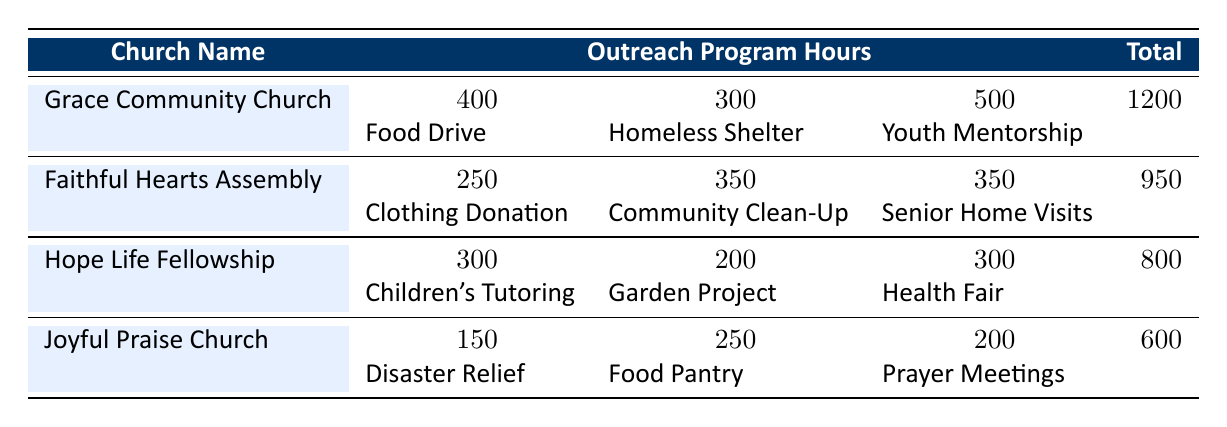What is the total number of volunteer hours contributed by Grace Community Church? According to the table, the total hours contributed by Grace Community Church is explicitly listed under the "Total" column. It shows 1200 hours.
Answer: 1200 Which outreach program received the most hours from Faithful Hearts Assembly? By checking the outreach program hours for Faithful Hearts Assembly, we find that the program "Community Clean-Up" has the highest recorded hours with 350 hours.
Answer: Community Clean-Up Is the total number of hours contributed by Joyful Praise Church greater than that of Hope Life Fellowship? The total hours for Joyful Praise Church is 600, while Hope Life Fellowship's total is 800. Since 600 is less than 800, the statement is false.
Answer: No What is the combined total of volunteer hours contributed by Hope Life Fellowship's outreach programs? We need to add the hours from each program: Children's Tutoring (300), Garden Project (200), and Health Fair (300). The sum is 300 + 200 + 300 = 800 hours.
Answer: 800 Which church has the least total volunteer hours, and what is that amount? By inspecting the "Total" column, we see that Joyful Praise Church has the least hours, totaling 600 hours.
Answer: Joyful Praise Church, 600 What is the average number of hours contributed by each outreach program in Grace Community Church? Grace Community Church has three outreach programs: Food Drive (400), Homeless Shelter Support (300), and Youth Mentorship (500). The total is 400 + 300 + 500 = 1200 hours. To find the average, divide by the number of programs (3): 1200 / 3 = 400.
Answer: 400 Did all outreach programs at Faithful Hearts Assembly contribute more than 200 hours? Evaluating the hours: Clothing Donation (250), Community Clean-Up (350), and Senior Home Visits (350). All programs contributed more than 200 hours, so this statement is true.
Answer: Yes Which two churches contributed more than 900 total volunteer hours combined? The two churches with hours above 900 are Grace Community Church (1200 hours) and Faithful Hearts Assembly (950 hours). Adding these gives 1200 + 950 = 2150 hours.
Answer: Grace Community Church and Faithful Hearts Assembly What percentage of total hours at Hope Life Fellowship was contributed to Children's Tutoring? Children's Tutoring hours are 300. The total hours for Hope Life Fellowship is 800. The percentage is calculated by (300 / 800) * 100 = 37.5%.
Answer: 37.5% 